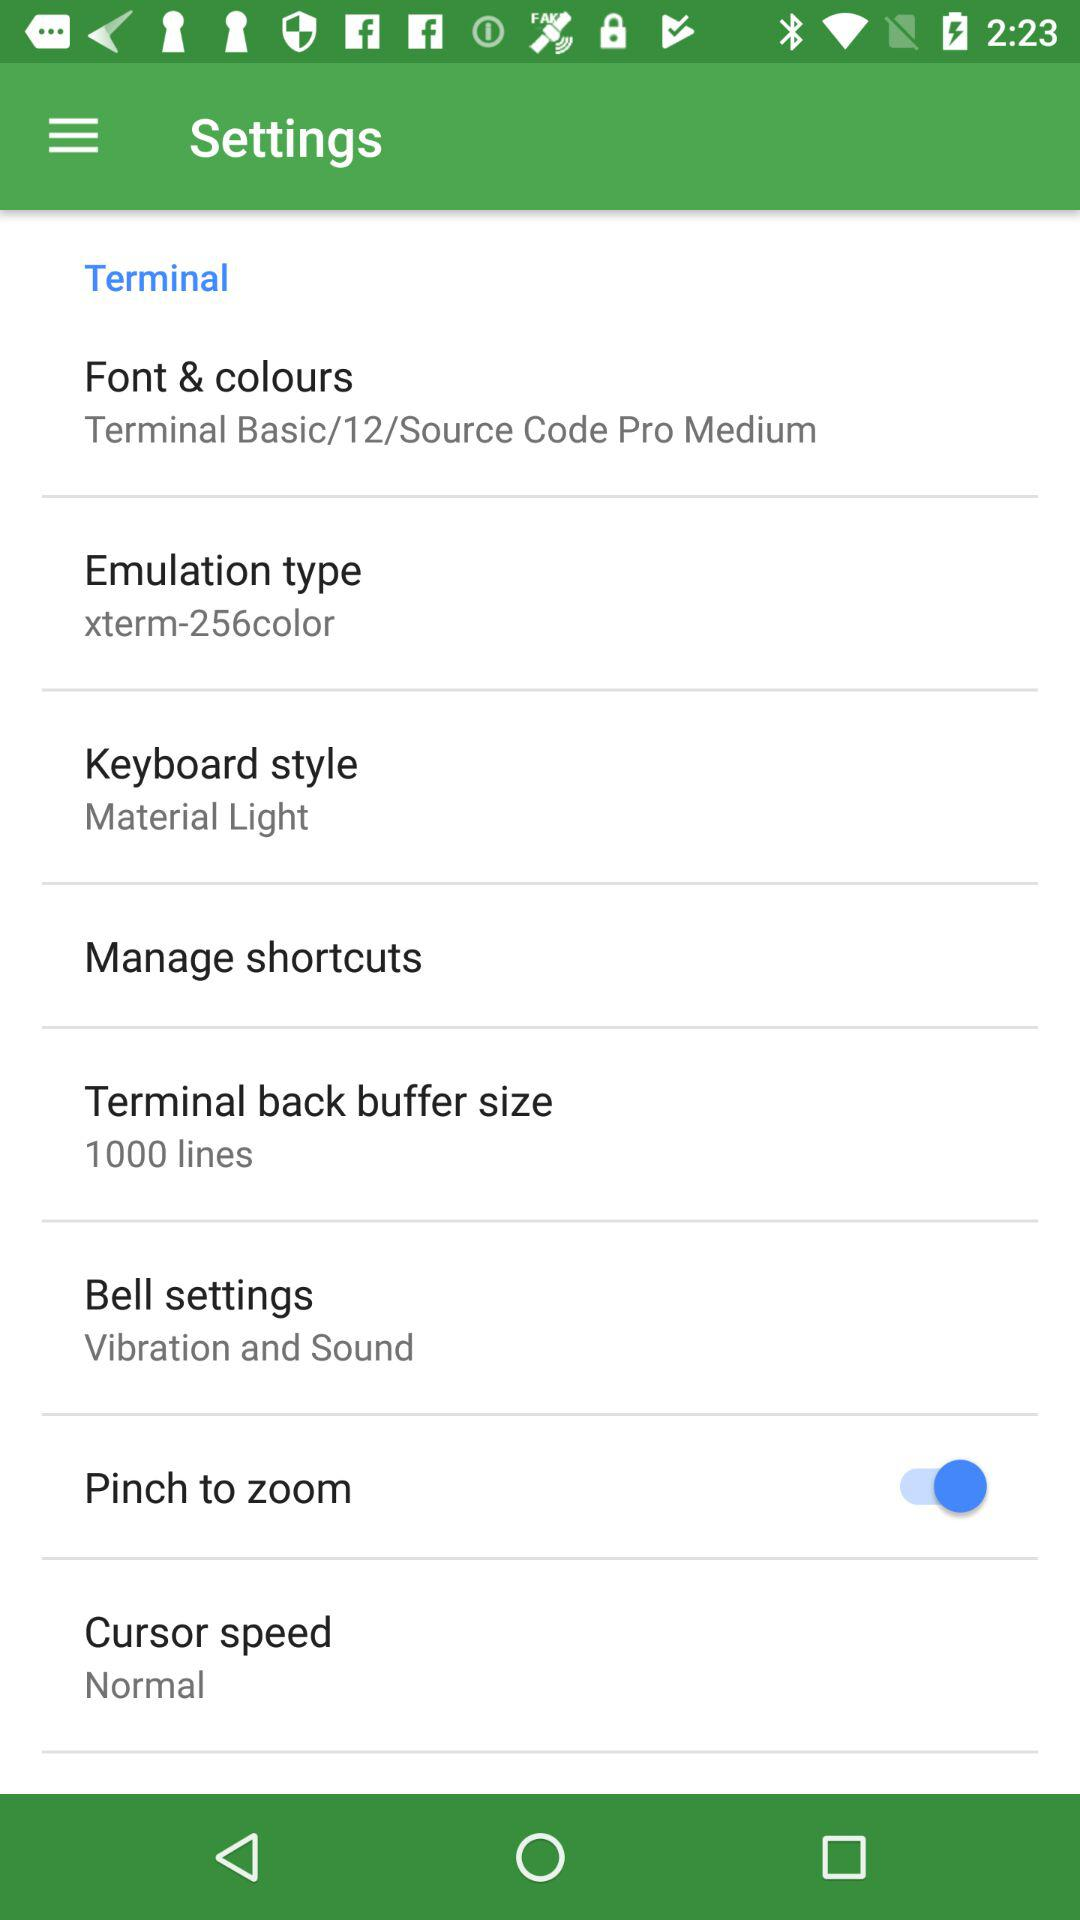What is the setting for the cursor speed? The setting is "Normal". 